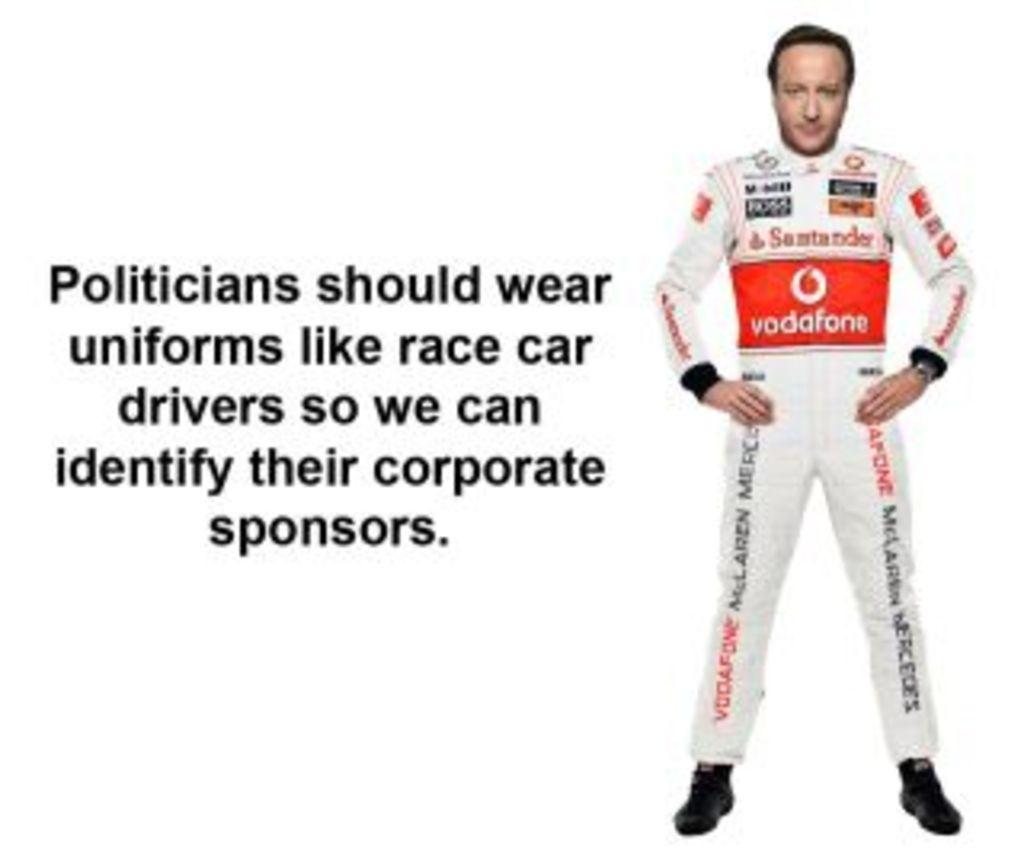<image>
Render a clear and concise summary of the photo. Man wearing a suit that says Vodafone on it. 